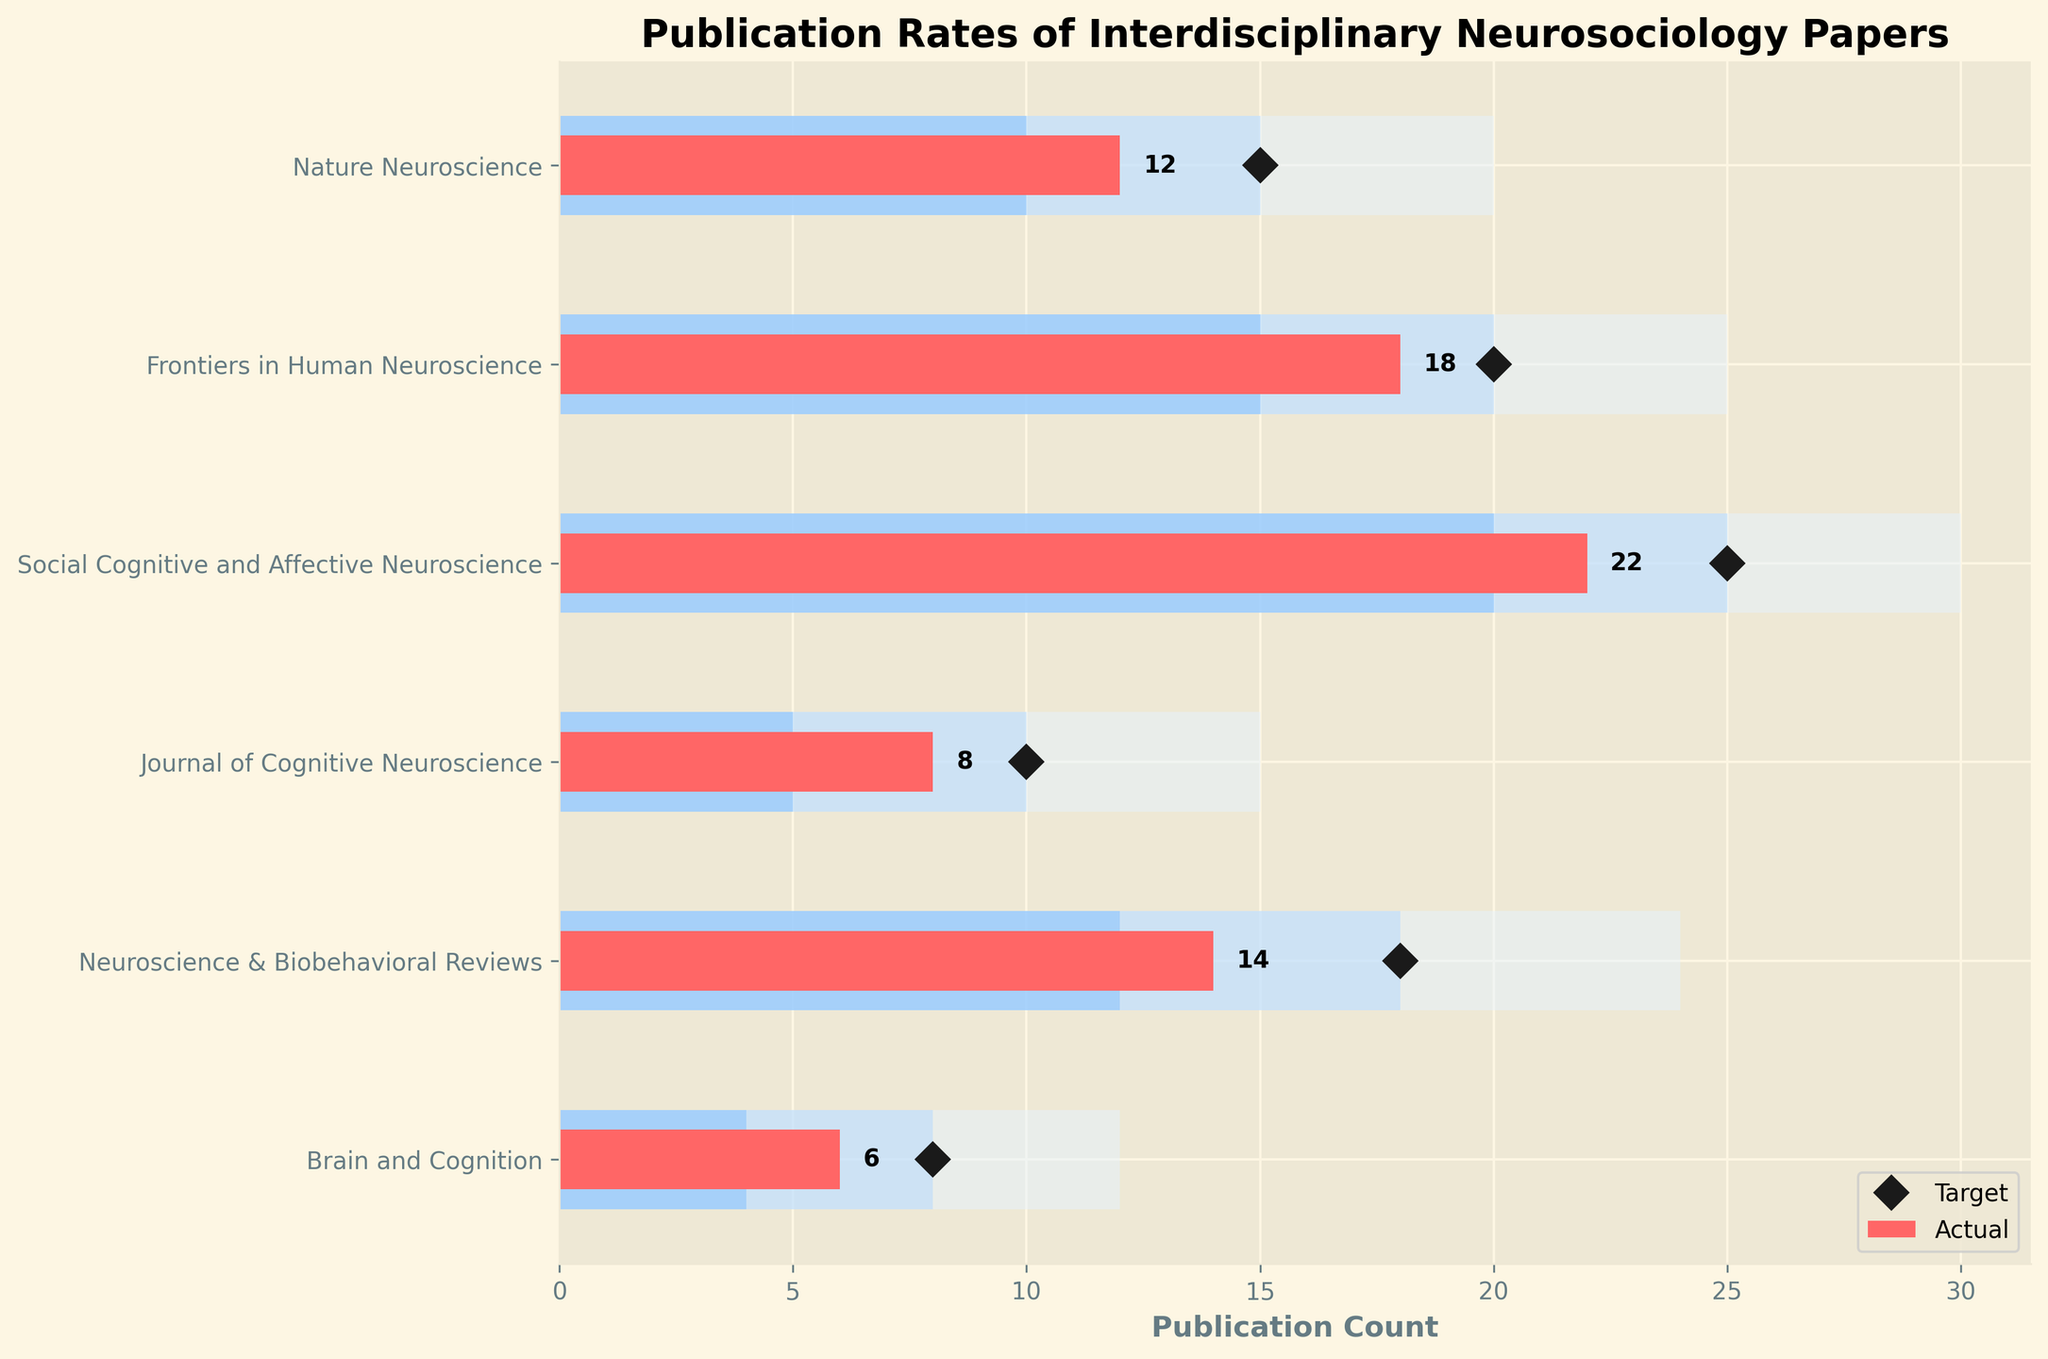What is the title of the chart? The title of the chart is typically found at the top of the figure and summarizes the content depicted. In this case, it reads "Publication Rates of Interdisciplinary Neurosociology Papers."
Answer: Publication Rates of Interdisciplinary Neurosociology Papers What is the target publication rate for the Journal of Cognitive Neuroscience? To find the target publication rate for the Journal of Cognitive Neuroscience, look at the data point marked as the target, which is a diamond marker, corresponding to this category.
Answer: 10 Which category has the highest actual publication rate? Look at the actual publication rates (represented by red bars) and identify the tallest bar. The category "Social Cognitive and Affective Neuroscience" has the highest actual publication rate.
Answer: Social Cognitive and Affective Neuroscience How does the actual publication rate of the Nature Neuroscience compare to its target? Locate the red bar for "Nature Neuroscience" and compare it to the target marker (diamond). The actual publication rate is 12 and the target is 15.
Answer: Below target Which journal has the closest actual publication rate to its target? To answer this, we need to find the category where the difference between the actual publication bar and the target marker (diamond) is the smallest. For "Neuroscience & Biobehavioral Reviews," this difference is just 4 (Actual: 14, Target: 18).
Answer: Neuroscience & Biobehavioral Reviews What is the range of the "Satisfactory" rating zone for all categories? For all categories, the "Satisfactory" zone is from 10 to 15 for Nature Neuroscience, from 15 to 20 for Frontiers in Human Neuroscience, from 20 to 25 for Social Cognitive and Affective Neuroscience, from 5 to 10 for the Journal of Cognitive Neuroscience, from 12 to 18 for Neuroscience & Biobehavioral Reviews, and from 4 to 8 for Brain and Cognition. Thus, the ranges for "Satisfactory" zones in all categories vary slightly from each other.
Answer: Varies by category How many categories have an actual publication rate within the "Poor" rating zone? To determine this, check the red bars (actual rates) and see if they fall within the "Poor" rating zones (0-10 for Nature Neuroscience, 0-15 for Frontiers in Human Neuroscience, 0-20 for Social Cognitive and Affective Neuroscience, 0-5 for Journal of Cognitive Neuroscience, 0-12 for Neuroscience & Biobehavioral Reviews, 0-4 for Brain and Cognition). Only the "Journal of Cognitive Neuroscience" and "Brain and Cognition" have actual rates in these zones.
Answer: Two categories Which categories meet their "Good" benchmarks? Check the red bar heights (actual publication rates) and see if they reach the "Good" benchmark section (darker middle blue bars). These values are 15 for Nature Neuroscience, 20 for Frontiers in Human Neuroscience, 25 for Social Cognitive and Affective Neuroscience, 10 for Journal of Cognitive Neuroscience, 18 for Neuroscience & Biobehavioral Reviews, and 8 for Brain and Cognition. Given the actual rates, only "Frontiers in Human Neuroscience" and "Social Cognitive and Affective Neuroscience" reach their "Good" benchmarks.
Answer: Frontiers in Human Neuroscience and Social Cognitive and Affective Neuroscience If you average the target publication rates across all categories, what do you get? Add all the target values together: 15 (Nature Neuroscience) + 20 (Frontiers in Human Neuroscience) + 25 (Social Cognitive and Affective Neuroscience) + 10 (Journal of Cognitive Neuroscience) + 18 (Neuroscience & Biobehavioral Reviews) + 8 (Brain and Cognition). Then, divide by the number of categories (6). The calculation is (15+20+25+10+18+8)/6 = 96/6 = 16.
Answer: 16 